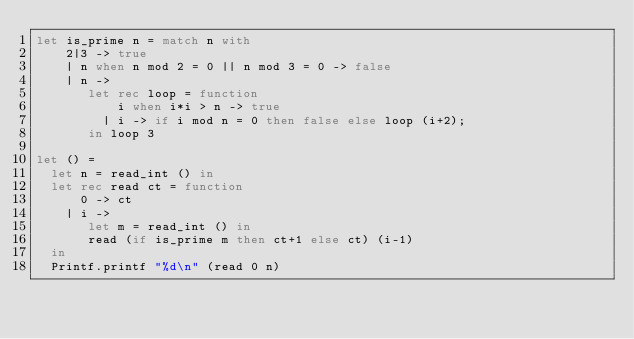Convert code to text. <code><loc_0><loc_0><loc_500><loc_500><_OCaml_>let is_prime n = match n with
    2|3 -> true
    | n when n mod 2 = 0 || n mod 3 = 0 -> false
    | n ->
       let rec loop = function
           i when i*i > n -> true
         | i -> if i mod n = 0 then false else loop (i+2);
       in loop 3

let () =
  let n = read_int () in
  let rec read ct = function
      0 -> ct
    | i ->
       let m = read_int () in
       read (if is_prime m then ct+1 else ct) (i-1)
  in
  Printf.printf "%d\n" (read 0 n)</code> 